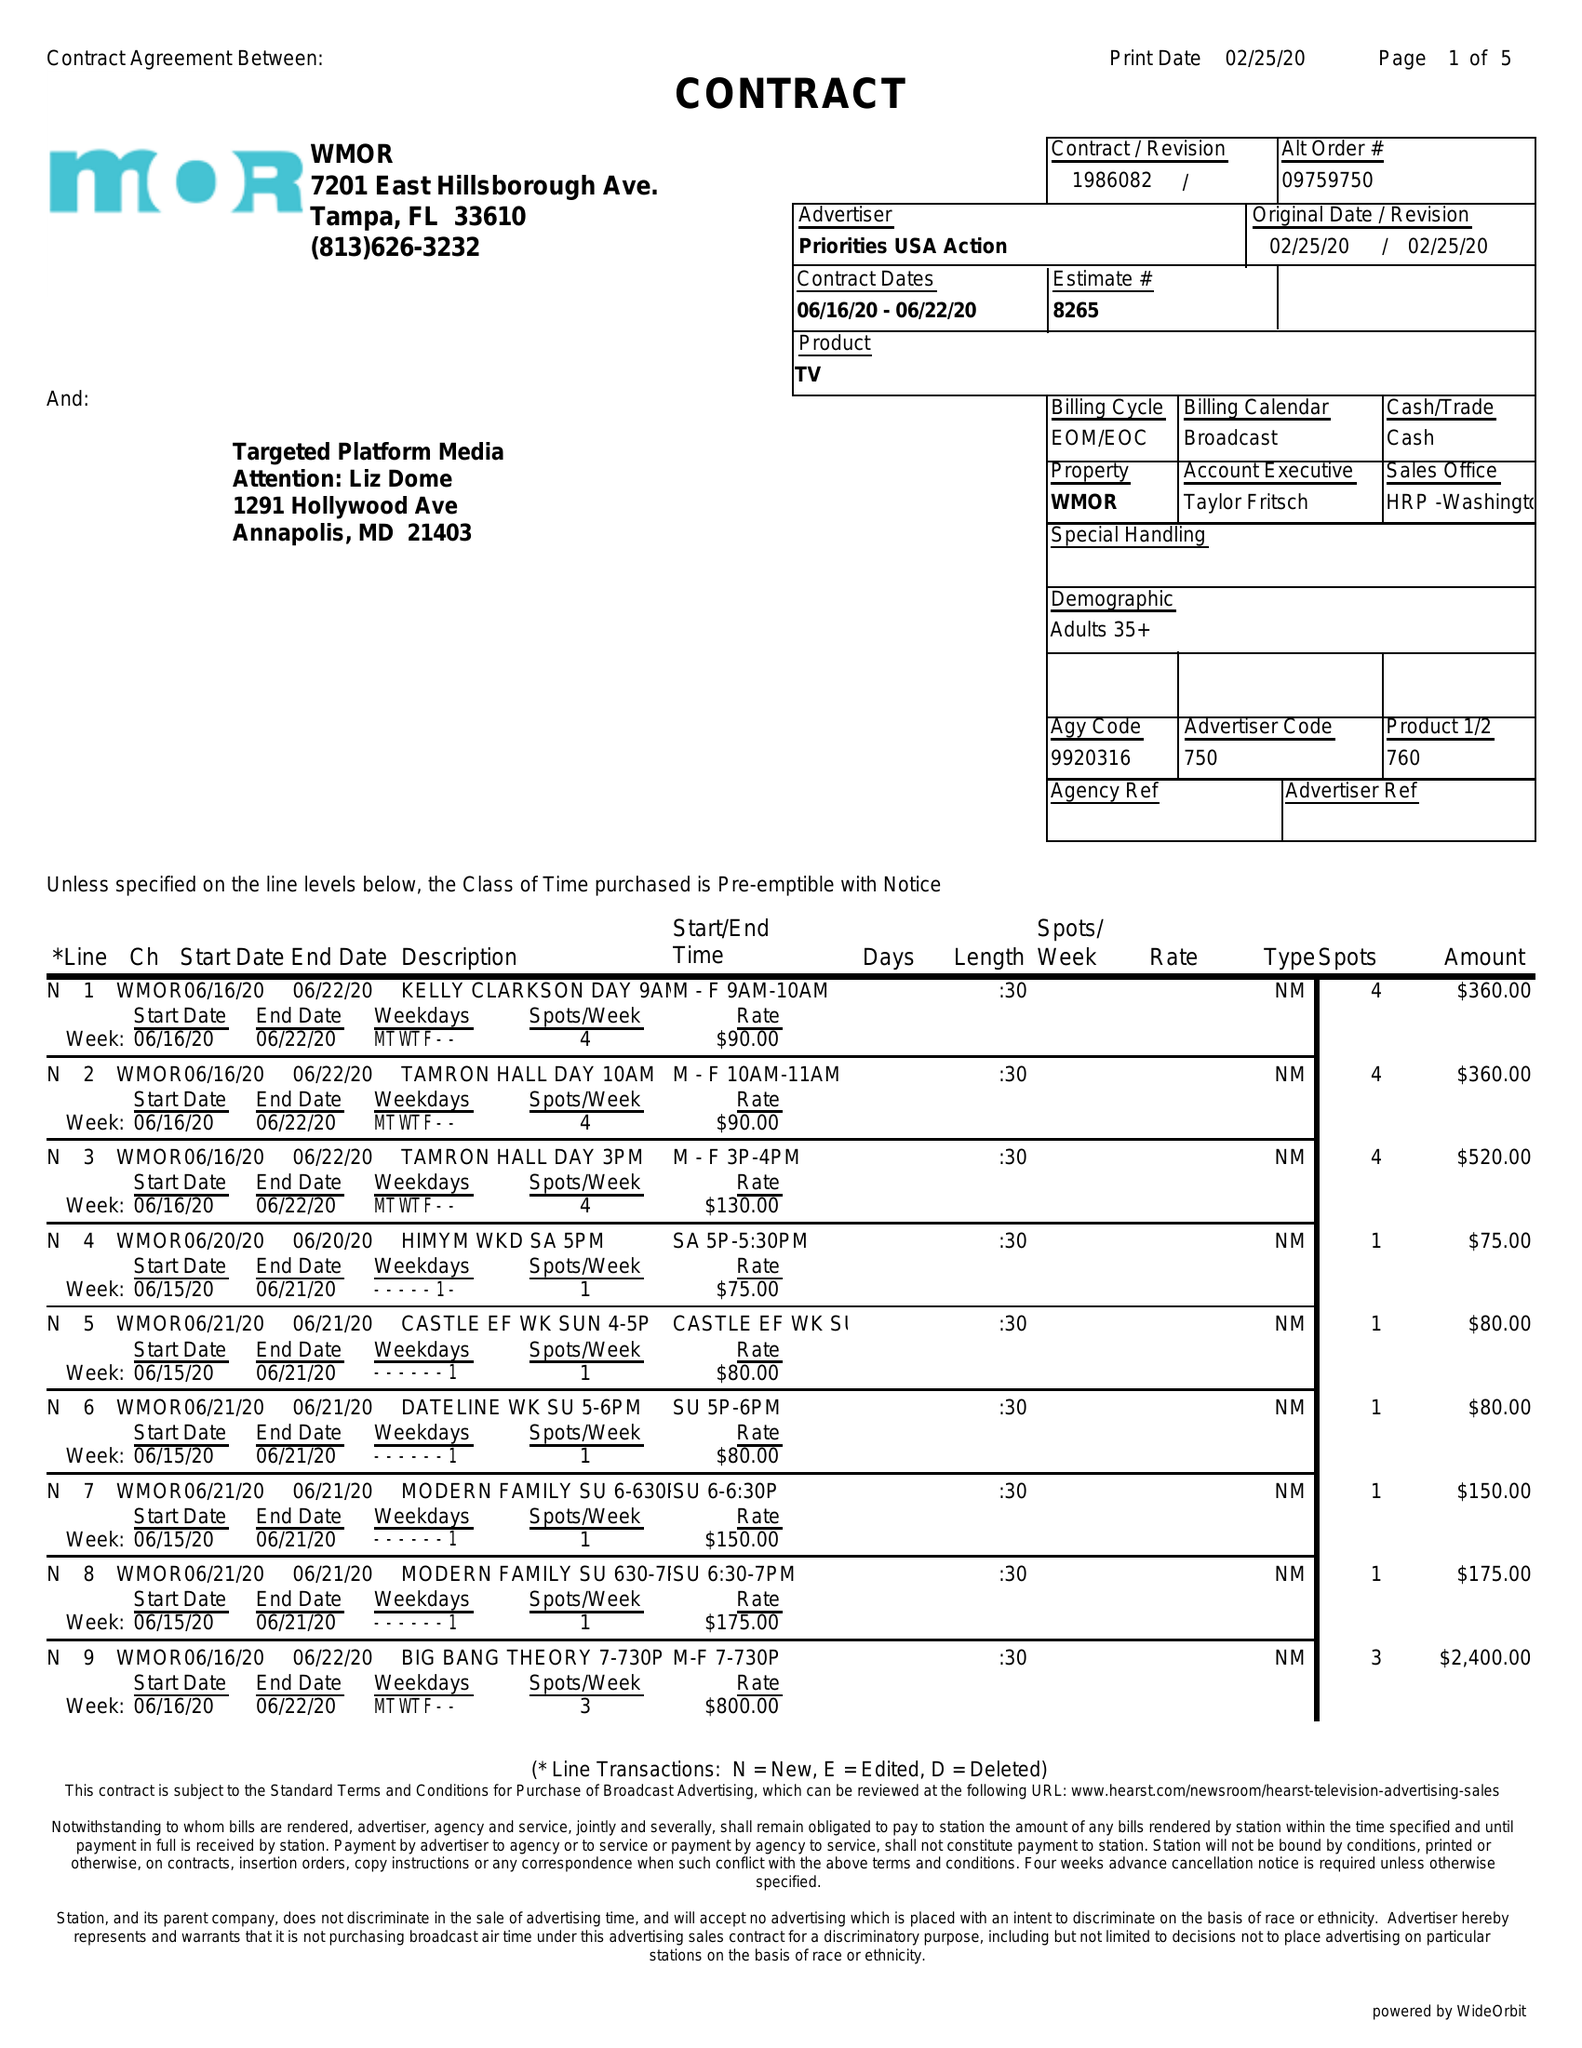What is the value for the contract_num?
Answer the question using a single word or phrase. 1986082 